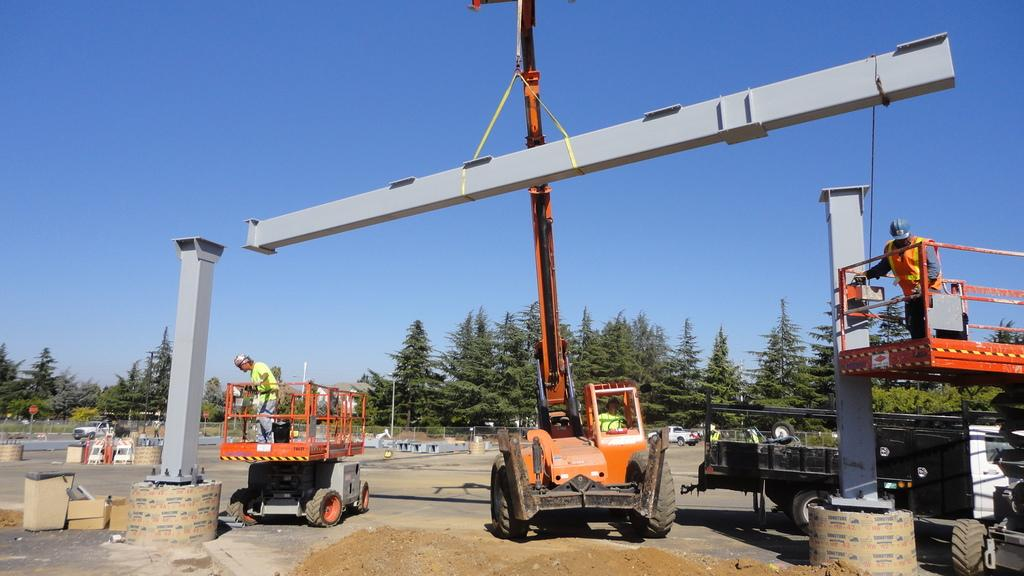What types of objects can be seen in the image? There are vehicles, trees, poles, and other objects on the ground in the image. Can you describe the natural elements in the image? There are trees present in the image. What is visible in the background of the image? The sky is visible in the background of the image. How many types of objects can be seen on the ground in the image? There are at least four types of objects on the ground in the image: vehicles, trees, poles, and other objects. What type of knowledge is being shared among the trees in the image? There is no indication in the image that the trees are sharing knowledge; they are simply trees. What industry is represented by the vehicles in the image? The image does not specify any particular industry associated with the vehicles; they are simply vehicles. 